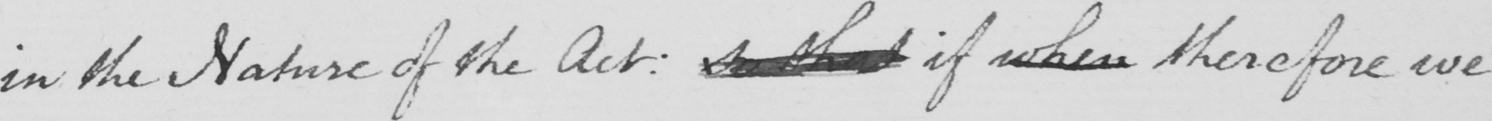Please provide the text content of this handwritten line. in the Nature of the Act :  so that if when therefore we 